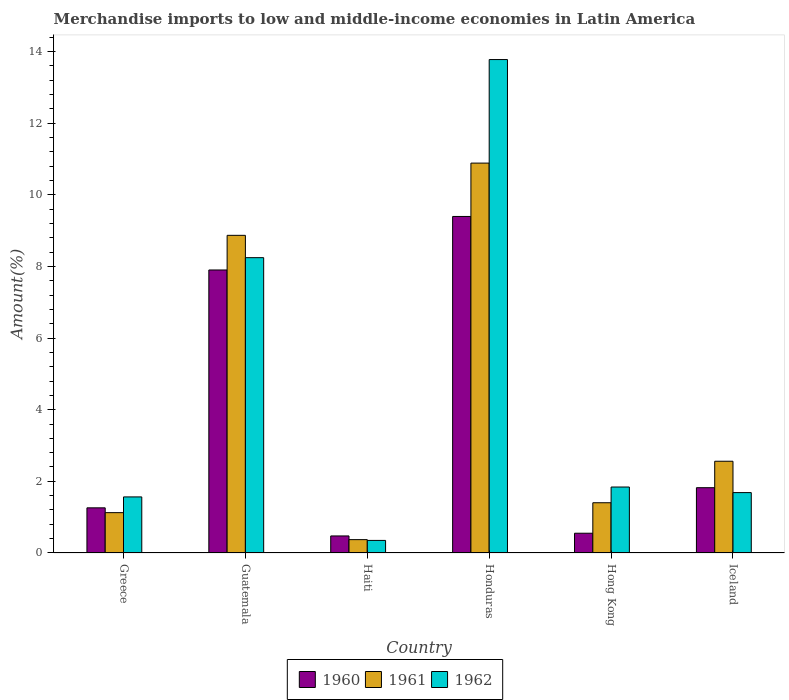How many groups of bars are there?
Your response must be concise. 6. Are the number of bars on each tick of the X-axis equal?
Keep it short and to the point. Yes. How many bars are there on the 3rd tick from the right?
Ensure brevity in your answer.  3. What is the percentage of amount earned from merchandise imports in 1960 in Hong Kong?
Offer a very short reply. 0.55. Across all countries, what is the maximum percentage of amount earned from merchandise imports in 1961?
Offer a very short reply. 10.88. Across all countries, what is the minimum percentage of amount earned from merchandise imports in 1961?
Provide a succinct answer. 0.37. In which country was the percentage of amount earned from merchandise imports in 1961 maximum?
Ensure brevity in your answer.  Honduras. In which country was the percentage of amount earned from merchandise imports in 1960 minimum?
Your answer should be very brief. Haiti. What is the total percentage of amount earned from merchandise imports in 1961 in the graph?
Keep it short and to the point. 25.21. What is the difference between the percentage of amount earned from merchandise imports in 1961 in Honduras and that in Hong Kong?
Ensure brevity in your answer.  9.48. What is the difference between the percentage of amount earned from merchandise imports in 1961 in Iceland and the percentage of amount earned from merchandise imports in 1960 in Guatemala?
Keep it short and to the point. -5.34. What is the average percentage of amount earned from merchandise imports in 1960 per country?
Make the answer very short. 3.57. What is the difference between the percentage of amount earned from merchandise imports of/in 1962 and percentage of amount earned from merchandise imports of/in 1961 in Honduras?
Provide a short and direct response. 2.89. What is the ratio of the percentage of amount earned from merchandise imports in 1962 in Guatemala to that in Hong Kong?
Make the answer very short. 4.48. Is the percentage of amount earned from merchandise imports in 1960 in Guatemala less than that in Haiti?
Give a very brief answer. No. Is the difference between the percentage of amount earned from merchandise imports in 1962 in Greece and Haiti greater than the difference between the percentage of amount earned from merchandise imports in 1961 in Greece and Haiti?
Make the answer very short. Yes. What is the difference between the highest and the second highest percentage of amount earned from merchandise imports in 1962?
Offer a very short reply. 6.4. What is the difference between the highest and the lowest percentage of amount earned from merchandise imports in 1960?
Your answer should be compact. 8.92. In how many countries, is the percentage of amount earned from merchandise imports in 1962 greater than the average percentage of amount earned from merchandise imports in 1962 taken over all countries?
Make the answer very short. 2. Is the sum of the percentage of amount earned from merchandise imports in 1960 in Guatemala and Haiti greater than the maximum percentage of amount earned from merchandise imports in 1962 across all countries?
Offer a very short reply. No. What does the 3rd bar from the left in Greece represents?
Give a very brief answer. 1962. Are all the bars in the graph horizontal?
Give a very brief answer. No. What is the difference between two consecutive major ticks on the Y-axis?
Provide a short and direct response. 2. Does the graph contain any zero values?
Make the answer very short. No. Does the graph contain grids?
Offer a terse response. No. Where does the legend appear in the graph?
Your answer should be compact. Bottom center. What is the title of the graph?
Keep it short and to the point. Merchandise imports to low and middle-income economies in Latin America. What is the label or title of the Y-axis?
Your response must be concise. Amount(%). What is the Amount(%) in 1960 in Greece?
Your answer should be very brief. 1.26. What is the Amount(%) of 1961 in Greece?
Ensure brevity in your answer.  1.13. What is the Amount(%) in 1962 in Greece?
Provide a short and direct response. 1.57. What is the Amount(%) of 1960 in Guatemala?
Your response must be concise. 7.9. What is the Amount(%) of 1961 in Guatemala?
Your answer should be very brief. 8.87. What is the Amount(%) of 1962 in Guatemala?
Provide a succinct answer. 8.24. What is the Amount(%) of 1960 in Haiti?
Provide a succinct answer. 0.48. What is the Amount(%) of 1961 in Haiti?
Provide a short and direct response. 0.37. What is the Amount(%) of 1962 in Haiti?
Keep it short and to the point. 0.35. What is the Amount(%) of 1960 in Honduras?
Make the answer very short. 9.39. What is the Amount(%) in 1961 in Honduras?
Give a very brief answer. 10.88. What is the Amount(%) in 1962 in Honduras?
Your response must be concise. 13.77. What is the Amount(%) in 1960 in Hong Kong?
Keep it short and to the point. 0.55. What is the Amount(%) of 1961 in Hong Kong?
Offer a very short reply. 1.4. What is the Amount(%) in 1962 in Hong Kong?
Provide a short and direct response. 1.84. What is the Amount(%) in 1960 in Iceland?
Provide a short and direct response. 1.82. What is the Amount(%) in 1961 in Iceland?
Your response must be concise. 2.56. What is the Amount(%) in 1962 in Iceland?
Provide a succinct answer. 1.69. Across all countries, what is the maximum Amount(%) of 1960?
Your answer should be very brief. 9.39. Across all countries, what is the maximum Amount(%) of 1961?
Provide a succinct answer. 10.88. Across all countries, what is the maximum Amount(%) in 1962?
Your response must be concise. 13.77. Across all countries, what is the minimum Amount(%) of 1960?
Your answer should be compact. 0.48. Across all countries, what is the minimum Amount(%) in 1961?
Provide a short and direct response. 0.37. Across all countries, what is the minimum Amount(%) of 1962?
Keep it short and to the point. 0.35. What is the total Amount(%) of 1960 in the graph?
Your response must be concise. 21.4. What is the total Amount(%) of 1961 in the graph?
Provide a short and direct response. 25.21. What is the total Amount(%) in 1962 in the graph?
Ensure brevity in your answer.  27.46. What is the difference between the Amount(%) of 1960 in Greece and that in Guatemala?
Ensure brevity in your answer.  -6.64. What is the difference between the Amount(%) of 1961 in Greece and that in Guatemala?
Your answer should be compact. -7.74. What is the difference between the Amount(%) in 1962 in Greece and that in Guatemala?
Ensure brevity in your answer.  -6.68. What is the difference between the Amount(%) in 1960 in Greece and that in Haiti?
Offer a terse response. 0.78. What is the difference between the Amount(%) of 1961 in Greece and that in Haiti?
Ensure brevity in your answer.  0.75. What is the difference between the Amount(%) of 1962 in Greece and that in Haiti?
Give a very brief answer. 1.21. What is the difference between the Amount(%) in 1960 in Greece and that in Honduras?
Make the answer very short. -8.13. What is the difference between the Amount(%) of 1961 in Greece and that in Honduras?
Your answer should be compact. -9.76. What is the difference between the Amount(%) of 1962 in Greece and that in Honduras?
Your answer should be compact. -12.21. What is the difference between the Amount(%) in 1960 in Greece and that in Hong Kong?
Give a very brief answer. 0.71. What is the difference between the Amount(%) in 1961 in Greece and that in Hong Kong?
Provide a succinct answer. -0.28. What is the difference between the Amount(%) of 1962 in Greece and that in Hong Kong?
Provide a short and direct response. -0.28. What is the difference between the Amount(%) in 1960 in Greece and that in Iceland?
Your response must be concise. -0.56. What is the difference between the Amount(%) of 1961 in Greece and that in Iceland?
Offer a very short reply. -1.43. What is the difference between the Amount(%) of 1962 in Greece and that in Iceland?
Provide a short and direct response. -0.12. What is the difference between the Amount(%) of 1960 in Guatemala and that in Haiti?
Ensure brevity in your answer.  7.42. What is the difference between the Amount(%) in 1961 in Guatemala and that in Haiti?
Offer a very short reply. 8.49. What is the difference between the Amount(%) in 1962 in Guatemala and that in Haiti?
Make the answer very short. 7.89. What is the difference between the Amount(%) in 1960 in Guatemala and that in Honduras?
Provide a short and direct response. -1.49. What is the difference between the Amount(%) in 1961 in Guatemala and that in Honduras?
Offer a terse response. -2.02. What is the difference between the Amount(%) of 1962 in Guatemala and that in Honduras?
Offer a very short reply. -5.53. What is the difference between the Amount(%) of 1960 in Guatemala and that in Hong Kong?
Make the answer very short. 7.35. What is the difference between the Amount(%) of 1961 in Guatemala and that in Hong Kong?
Make the answer very short. 7.46. What is the difference between the Amount(%) of 1962 in Guatemala and that in Hong Kong?
Your response must be concise. 6.4. What is the difference between the Amount(%) in 1960 in Guatemala and that in Iceland?
Offer a terse response. 6.08. What is the difference between the Amount(%) of 1961 in Guatemala and that in Iceland?
Offer a terse response. 6.3. What is the difference between the Amount(%) of 1962 in Guatemala and that in Iceland?
Your response must be concise. 6.56. What is the difference between the Amount(%) in 1960 in Haiti and that in Honduras?
Provide a short and direct response. -8.92. What is the difference between the Amount(%) in 1961 in Haiti and that in Honduras?
Provide a short and direct response. -10.51. What is the difference between the Amount(%) in 1962 in Haiti and that in Honduras?
Your answer should be very brief. -13.42. What is the difference between the Amount(%) in 1960 in Haiti and that in Hong Kong?
Offer a very short reply. -0.08. What is the difference between the Amount(%) of 1961 in Haiti and that in Hong Kong?
Give a very brief answer. -1.03. What is the difference between the Amount(%) of 1962 in Haiti and that in Hong Kong?
Provide a succinct answer. -1.49. What is the difference between the Amount(%) of 1960 in Haiti and that in Iceland?
Your response must be concise. -1.35. What is the difference between the Amount(%) of 1961 in Haiti and that in Iceland?
Provide a succinct answer. -2.19. What is the difference between the Amount(%) of 1962 in Haiti and that in Iceland?
Make the answer very short. -1.33. What is the difference between the Amount(%) in 1960 in Honduras and that in Hong Kong?
Offer a very short reply. 8.84. What is the difference between the Amount(%) in 1961 in Honduras and that in Hong Kong?
Your answer should be very brief. 9.48. What is the difference between the Amount(%) in 1962 in Honduras and that in Hong Kong?
Your answer should be very brief. 11.93. What is the difference between the Amount(%) of 1960 in Honduras and that in Iceland?
Provide a succinct answer. 7.57. What is the difference between the Amount(%) of 1961 in Honduras and that in Iceland?
Offer a terse response. 8.32. What is the difference between the Amount(%) in 1962 in Honduras and that in Iceland?
Provide a short and direct response. 12.09. What is the difference between the Amount(%) of 1960 in Hong Kong and that in Iceland?
Your answer should be very brief. -1.27. What is the difference between the Amount(%) in 1961 in Hong Kong and that in Iceland?
Your answer should be compact. -1.16. What is the difference between the Amount(%) in 1962 in Hong Kong and that in Iceland?
Keep it short and to the point. 0.16. What is the difference between the Amount(%) of 1960 in Greece and the Amount(%) of 1961 in Guatemala?
Keep it short and to the point. -7.61. What is the difference between the Amount(%) in 1960 in Greece and the Amount(%) in 1962 in Guatemala?
Make the answer very short. -6.98. What is the difference between the Amount(%) in 1961 in Greece and the Amount(%) in 1962 in Guatemala?
Offer a terse response. -7.12. What is the difference between the Amount(%) in 1960 in Greece and the Amount(%) in 1961 in Haiti?
Give a very brief answer. 0.89. What is the difference between the Amount(%) of 1961 in Greece and the Amount(%) of 1962 in Haiti?
Provide a short and direct response. 0.77. What is the difference between the Amount(%) in 1960 in Greece and the Amount(%) in 1961 in Honduras?
Make the answer very short. -9.62. What is the difference between the Amount(%) in 1960 in Greece and the Amount(%) in 1962 in Honduras?
Offer a terse response. -12.51. What is the difference between the Amount(%) of 1961 in Greece and the Amount(%) of 1962 in Honduras?
Ensure brevity in your answer.  -12.65. What is the difference between the Amount(%) of 1960 in Greece and the Amount(%) of 1961 in Hong Kong?
Your answer should be very brief. -0.14. What is the difference between the Amount(%) of 1960 in Greece and the Amount(%) of 1962 in Hong Kong?
Offer a very short reply. -0.58. What is the difference between the Amount(%) in 1961 in Greece and the Amount(%) in 1962 in Hong Kong?
Ensure brevity in your answer.  -0.71. What is the difference between the Amount(%) of 1960 in Greece and the Amount(%) of 1961 in Iceland?
Make the answer very short. -1.3. What is the difference between the Amount(%) of 1960 in Greece and the Amount(%) of 1962 in Iceland?
Offer a very short reply. -0.43. What is the difference between the Amount(%) of 1961 in Greece and the Amount(%) of 1962 in Iceland?
Provide a succinct answer. -0.56. What is the difference between the Amount(%) of 1960 in Guatemala and the Amount(%) of 1961 in Haiti?
Ensure brevity in your answer.  7.53. What is the difference between the Amount(%) of 1960 in Guatemala and the Amount(%) of 1962 in Haiti?
Ensure brevity in your answer.  7.55. What is the difference between the Amount(%) of 1961 in Guatemala and the Amount(%) of 1962 in Haiti?
Your response must be concise. 8.51. What is the difference between the Amount(%) of 1960 in Guatemala and the Amount(%) of 1961 in Honduras?
Offer a very short reply. -2.98. What is the difference between the Amount(%) of 1960 in Guatemala and the Amount(%) of 1962 in Honduras?
Offer a very short reply. -5.87. What is the difference between the Amount(%) in 1961 in Guatemala and the Amount(%) in 1962 in Honduras?
Your answer should be compact. -4.91. What is the difference between the Amount(%) in 1960 in Guatemala and the Amount(%) in 1961 in Hong Kong?
Your answer should be compact. 6.5. What is the difference between the Amount(%) of 1960 in Guatemala and the Amount(%) of 1962 in Hong Kong?
Provide a succinct answer. 6.06. What is the difference between the Amount(%) in 1961 in Guatemala and the Amount(%) in 1962 in Hong Kong?
Your response must be concise. 7.02. What is the difference between the Amount(%) in 1960 in Guatemala and the Amount(%) in 1961 in Iceland?
Keep it short and to the point. 5.34. What is the difference between the Amount(%) of 1960 in Guatemala and the Amount(%) of 1962 in Iceland?
Offer a very short reply. 6.21. What is the difference between the Amount(%) of 1961 in Guatemala and the Amount(%) of 1962 in Iceland?
Make the answer very short. 7.18. What is the difference between the Amount(%) in 1960 in Haiti and the Amount(%) in 1961 in Honduras?
Provide a succinct answer. -10.41. What is the difference between the Amount(%) of 1960 in Haiti and the Amount(%) of 1962 in Honduras?
Keep it short and to the point. -13.3. What is the difference between the Amount(%) in 1961 in Haiti and the Amount(%) in 1962 in Honduras?
Ensure brevity in your answer.  -13.4. What is the difference between the Amount(%) of 1960 in Haiti and the Amount(%) of 1961 in Hong Kong?
Your answer should be very brief. -0.93. What is the difference between the Amount(%) in 1960 in Haiti and the Amount(%) in 1962 in Hong Kong?
Provide a succinct answer. -1.37. What is the difference between the Amount(%) in 1961 in Haiti and the Amount(%) in 1962 in Hong Kong?
Give a very brief answer. -1.47. What is the difference between the Amount(%) in 1960 in Haiti and the Amount(%) in 1961 in Iceland?
Provide a short and direct response. -2.08. What is the difference between the Amount(%) of 1960 in Haiti and the Amount(%) of 1962 in Iceland?
Ensure brevity in your answer.  -1.21. What is the difference between the Amount(%) of 1961 in Haiti and the Amount(%) of 1962 in Iceland?
Provide a short and direct response. -1.31. What is the difference between the Amount(%) of 1960 in Honduras and the Amount(%) of 1961 in Hong Kong?
Your response must be concise. 7.99. What is the difference between the Amount(%) in 1960 in Honduras and the Amount(%) in 1962 in Hong Kong?
Give a very brief answer. 7.55. What is the difference between the Amount(%) in 1961 in Honduras and the Amount(%) in 1962 in Hong Kong?
Your answer should be compact. 9.04. What is the difference between the Amount(%) of 1960 in Honduras and the Amount(%) of 1961 in Iceland?
Your answer should be compact. 6.83. What is the difference between the Amount(%) in 1960 in Honduras and the Amount(%) in 1962 in Iceland?
Your response must be concise. 7.71. What is the difference between the Amount(%) in 1961 in Honduras and the Amount(%) in 1962 in Iceland?
Keep it short and to the point. 9.2. What is the difference between the Amount(%) in 1960 in Hong Kong and the Amount(%) in 1961 in Iceland?
Your response must be concise. -2.01. What is the difference between the Amount(%) of 1960 in Hong Kong and the Amount(%) of 1962 in Iceland?
Keep it short and to the point. -1.13. What is the difference between the Amount(%) of 1961 in Hong Kong and the Amount(%) of 1962 in Iceland?
Make the answer very short. -0.28. What is the average Amount(%) in 1960 per country?
Offer a terse response. 3.57. What is the average Amount(%) of 1961 per country?
Keep it short and to the point. 4.2. What is the average Amount(%) of 1962 per country?
Make the answer very short. 4.58. What is the difference between the Amount(%) in 1960 and Amount(%) in 1961 in Greece?
Offer a terse response. 0.13. What is the difference between the Amount(%) of 1960 and Amount(%) of 1962 in Greece?
Your response must be concise. -0.3. What is the difference between the Amount(%) in 1961 and Amount(%) in 1962 in Greece?
Ensure brevity in your answer.  -0.44. What is the difference between the Amount(%) of 1960 and Amount(%) of 1961 in Guatemala?
Offer a terse response. -0.97. What is the difference between the Amount(%) of 1960 and Amount(%) of 1962 in Guatemala?
Give a very brief answer. -0.34. What is the difference between the Amount(%) in 1961 and Amount(%) in 1962 in Guatemala?
Make the answer very short. 0.62. What is the difference between the Amount(%) in 1960 and Amount(%) in 1961 in Haiti?
Keep it short and to the point. 0.1. What is the difference between the Amount(%) in 1960 and Amount(%) in 1962 in Haiti?
Keep it short and to the point. 0.12. What is the difference between the Amount(%) of 1961 and Amount(%) of 1962 in Haiti?
Ensure brevity in your answer.  0.02. What is the difference between the Amount(%) in 1960 and Amount(%) in 1961 in Honduras?
Provide a succinct answer. -1.49. What is the difference between the Amount(%) of 1960 and Amount(%) of 1962 in Honduras?
Your answer should be very brief. -4.38. What is the difference between the Amount(%) of 1961 and Amount(%) of 1962 in Honduras?
Provide a short and direct response. -2.89. What is the difference between the Amount(%) of 1960 and Amount(%) of 1961 in Hong Kong?
Make the answer very short. -0.85. What is the difference between the Amount(%) in 1960 and Amount(%) in 1962 in Hong Kong?
Provide a succinct answer. -1.29. What is the difference between the Amount(%) in 1961 and Amount(%) in 1962 in Hong Kong?
Make the answer very short. -0.44. What is the difference between the Amount(%) in 1960 and Amount(%) in 1961 in Iceland?
Provide a short and direct response. -0.74. What is the difference between the Amount(%) of 1960 and Amount(%) of 1962 in Iceland?
Provide a succinct answer. 0.14. What is the difference between the Amount(%) in 1961 and Amount(%) in 1962 in Iceland?
Your answer should be very brief. 0.88. What is the ratio of the Amount(%) in 1960 in Greece to that in Guatemala?
Your answer should be compact. 0.16. What is the ratio of the Amount(%) in 1961 in Greece to that in Guatemala?
Provide a succinct answer. 0.13. What is the ratio of the Amount(%) in 1962 in Greece to that in Guatemala?
Your response must be concise. 0.19. What is the ratio of the Amount(%) in 1960 in Greece to that in Haiti?
Your answer should be very brief. 2.65. What is the ratio of the Amount(%) in 1961 in Greece to that in Haiti?
Give a very brief answer. 3.02. What is the ratio of the Amount(%) in 1962 in Greece to that in Haiti?
Keep it short and to the point. 4.46. What is the ratio of the Amount(%) of 1960 in Greece to that in Honduras?
Give a very brief answer. 0.13. What is the ratio of the Amount(%) in 1961 in Greece to that in Honduras?
Ensure brevity in your answer.  0.1. What is the ratio of the Amount(%) of 1962 in Greece to that in Honduras?
Ensure brevity in your answer.  0.11. What is the ratio of the Amount(%) of 1960 in Greece to that in Hong Kong?
Keep it short and to the point. 2.29. What is the ratio of the Amount(%) of 1961 in Greece to that in Hong Kong?
Ensure brevity in your answer.  0.8. What is the ratio of the Amount(%) of 1962 in Greece to that in Hong Kong?
Your answer should be compact. 0.85. What is the ratio of the Amount(%) in 1960 in Greece to that in Iceland?
Provide a short and direct response. 0.69. What is the ratio of the Amount(%) of 1961 in Greece to that in Iceland?
Provide a succinct answer. 0.44. What is the ratio of the Amount(%) in 1962 in Greece to that in Iceland?
Ensure brevity in your answer.  0.93. What is the ratio of the Amount(%) of 1960 in Guatemala to that in Haiti?
Keep it short and to the point. 16.61. What is the ratio of the Amount(%) in 1961 in Guatemala to that in Haiti?
Offer a terse response. 23.77. What is the ratio of the Amount(%) of 1962 in Guatemala to that in Haiti?
Provide a short and direct response. 23.47. What is the ratio of the Amount(%) in 1960 in Guatemala to that in Honduras?
Your response must be concise. 0.84. What is the ratio of the Amount(%) of 1961 in Guatemala to that in Honduras?
Keep it short and to the point. 0.81. What is the ratio of the Amount(%) of 1962 in Guatemala to that in Honduras?
Offer a terse response. 0.6. What is the ratio of the Amount(%) in 1960 in Guatemala to that in Hong Kong?
Offer a terse response. 14.33. What is the ratio of the Amount(%) in 1961 in Guatemala to that in Hong Kong?
Your response must be concise. 6.32. What is the ratio of the Amount(%) of 1962 in Guatemala to that in Hong Kong?
Provide a short and direct response. 4.48. What is the ratio of the Amount(%) in 1960 in Guatemala to that in Iceland?
Give a very brief answer. 4.33. What is the ratio of the Amount(%) of 1961 in Guatemala to that in Iceland?
Keep it short and to the point. 3.46. What is the ratio of the Amount(%) in 1962 in Guatemala to that in Iceland?
Your response must be concise. 4.89. What is the ratio of the Amount(%) of 1960 in Haiti to that in Honduras?
Give a very brief answer. 0.05. What is the ratio of the Amount(%) of 1961 in Haiti to that in Honduras?
Provide a short and direct response. 0.03. What is the ratio of the Amount(%) of 1962 in Haiti to that in Honduras?
Your answer should be compact. 0.03. What is the ratio of the Amount(%) of 1960 in Haiti to that in Hong Kong?
Your answer should be very brief. 0.86. What is the ratio of the Amount(%) of 1961 in Haiti to that in Hong Kong?
Your response must be concise. 0.27. What is the ratio of the Amount(%) in 1962 in Haiti to that in Hong Kong?
Provide a succinct answer. 0.19. What is the ratio of the Amount(%) of 1960 in Haiti to that in Iceland?
Your answer should be compact. 0.26. What is the ratio of the Amount(%) in 1961 in Haiti to that in Iceland?
Give a very brief answer. 0.15. What is the ratio of the Amount(%) in 1962 in Haiti to that in Iceland?
Offer a very short reply. 0.21. What is the ratio of the Amount(%) of 1960 in Honduras to that in Hong Kong?
Provide a succinct answer. 17.03. What is the ratio of the Amount(%) in 1961 in Honduras to that in Hong Kong?
Give a very brief answer. 7.76. What is the ratio of the Amount(%) of 1962 in Honduras to that in Hong Kong?
Keep it short and to the point. 7.48. What is the ratio of the Amount(%) of 1960 in Honduras to that in Iceland?
Your answer should be compact. 5.15. What is the ratio of the Amount(%) of 1961 in Honduras to that in Iceland?
Give a very brief answer. 4.25. What is the ratio of the Amount(%) in 1962 in Honduras to that in Iceland?
Offer a terse response. 8.17. What is the ratio of the Amount(%) of 1960 in Hong Kong to that in Iceland?
Your answer should be very brief. 0.3. What is the ratio of the Amount(%) of 1961 in Hong Kong to that in Iceland?
Your answer should be compact. 0.55. What is the ratio of the Amount(%) in 1962 in Hong Kong to that in Iceland?
Keep it short and to the point. 1.09. What is the difference between the highest and the second highest Amount(%) in 1960?
Give a very brief answer. 1.49. What is the difference between the highest and the second highest Amount(%) of 1961?
Ensure brevity in your answer.  2.02. What is the difference between the highest and the second highest Amount(%) of 1962?
Provide a succinct answer. 5.53. What is the difference between the highest and the lowest Amount(%) of 1960?
Ensure brevity in your answer.  8.92. What is the difference between the highest and the lowest Amount(%) in 1961?
Ensure brevity in your answer.  10.51. What is the difference between the highest and the lowest Amount(%) of 1962?
Your answer should be compact. 13.42. 